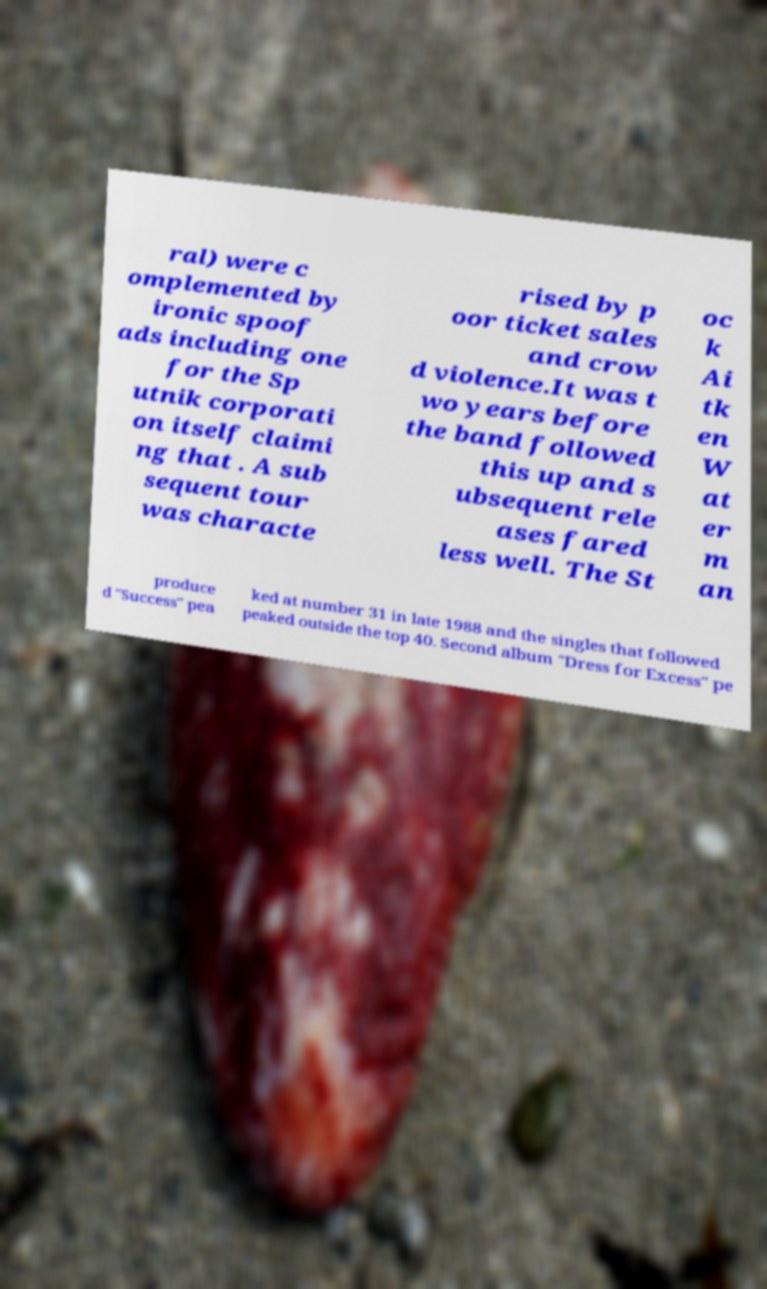Could you assist in decoding the text presented in this image and type it out clearly? ral) were c omplemented by ironic spoof ads including one for the Sp utnik corporati on itself claimi ng that . A sub sequent tour was characte rised by p oor ticket sales and crow d violence.It was t wo years before the band followed this up and s ubsequent rele ases fared less well. The St oc k Ai tk en W at er m an produce d "Success" pea ked at number 31 in late 1988 and the singles that followed peaked outside the top 40. Second album "Dress for Excess" pe 